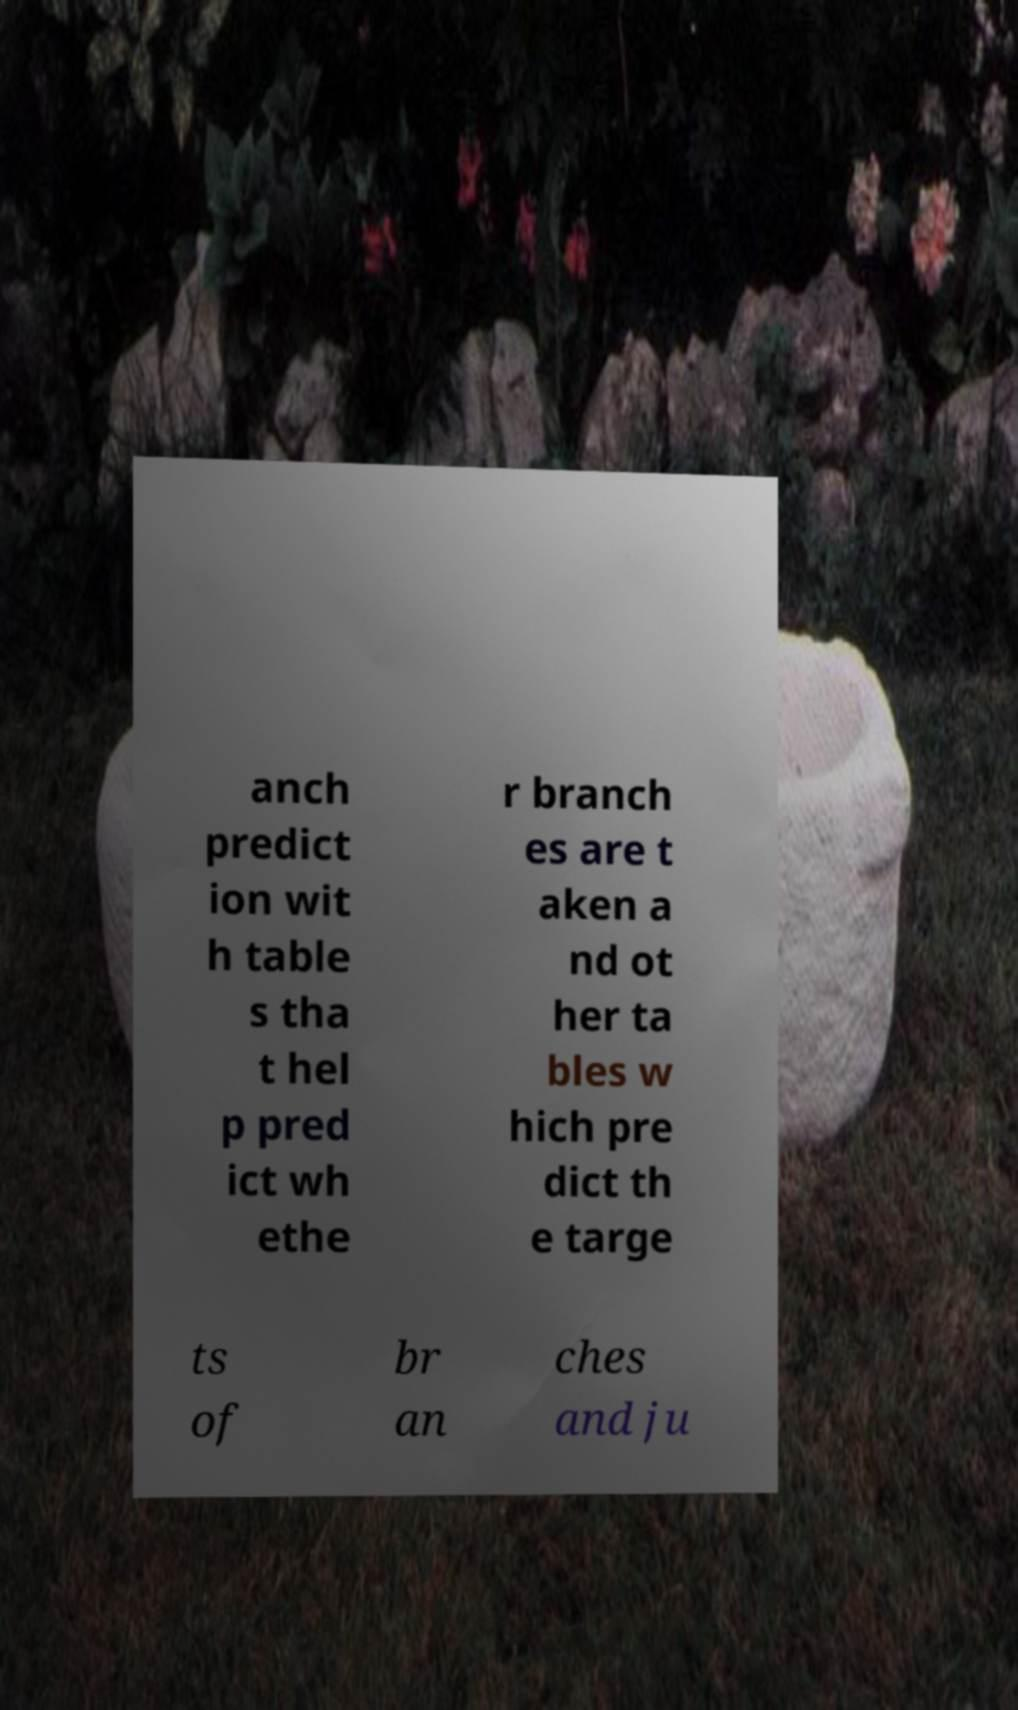There's text embedded in this image that I need extracted. Can you transcribe it verbatim? anch predict ion wit h table s tha t hel p pred ict wh ethe r branch es are t aken a nd ot her ta bles w hich pre dict th e targe ts of br an ches and ju 